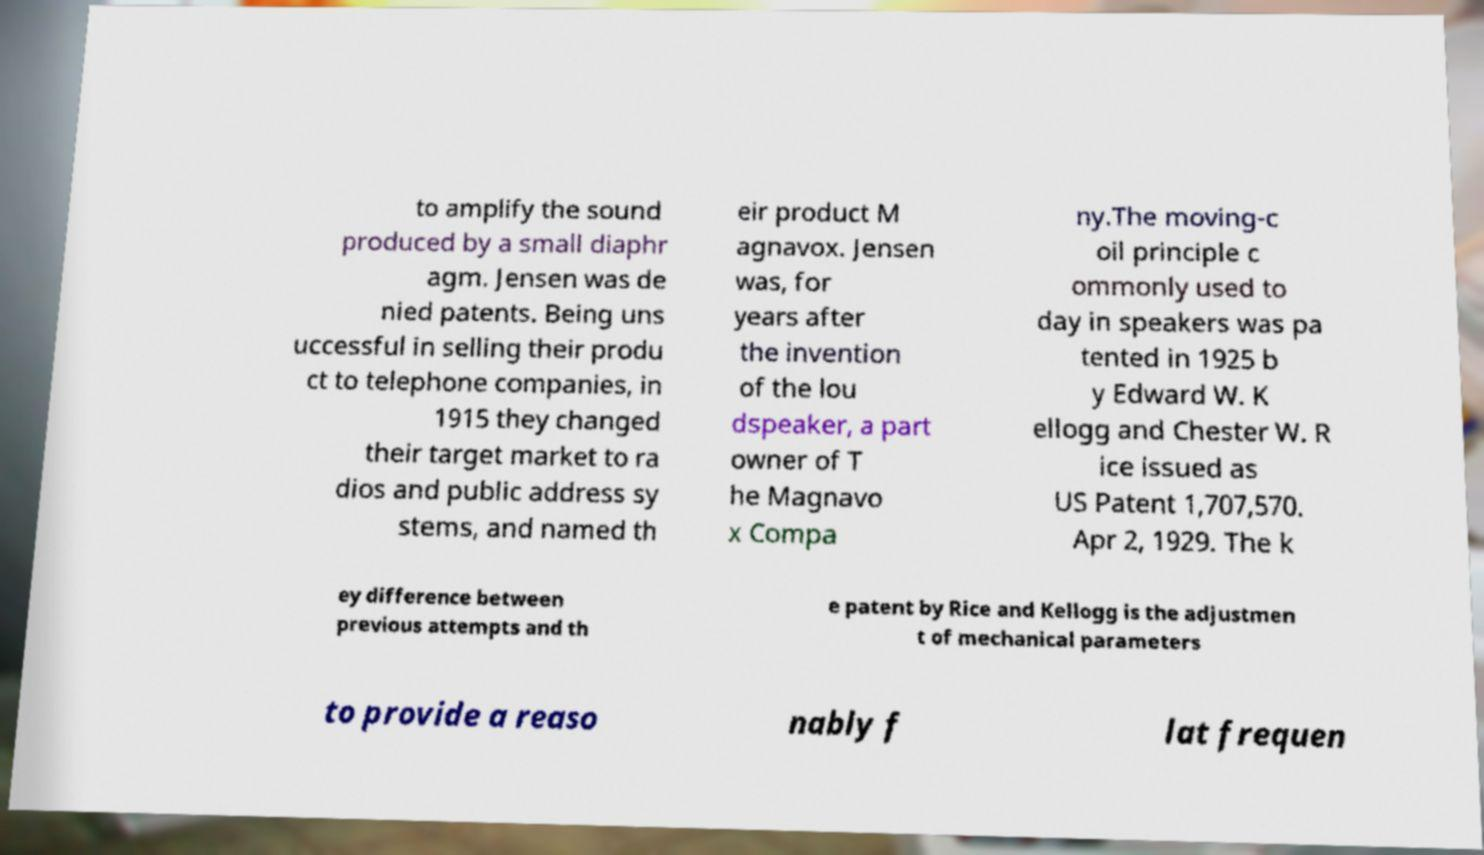Could you extract and type out the text from this image? to amplify the sound produced by a small diaphr agm. Jensen was de nied patents. Being uns uccessful in selling their produ ct to telephone companies, in 1915 they changed their target market to ra dios and public address sy stems, and named th eir product M agnavox. Jensen was, for years after the invention of the lou dspeaker, a part owner of T he Magnavo x Compa ny.The moving-c oil principle c ommonly used to day in speakers was pa tented in 1925 b y Edward W. K ellogg and Chester W. R ice issued as US Patent 1,707,570. Apr 2, 1929. The k ey difference between previous attempts and th e patent by Rice and Kellogg is the adjustmen t of mechanical parameters to provide a reaso nably f lat frequen 